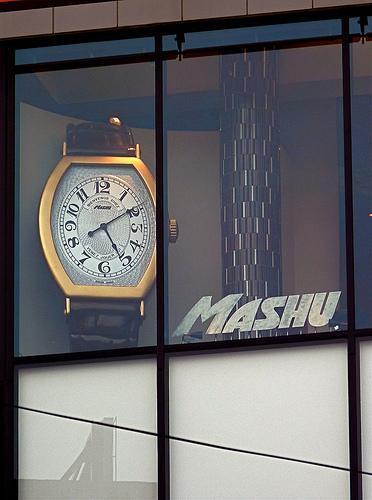How many watches are in the window?
Give a very brief answer. 1. 